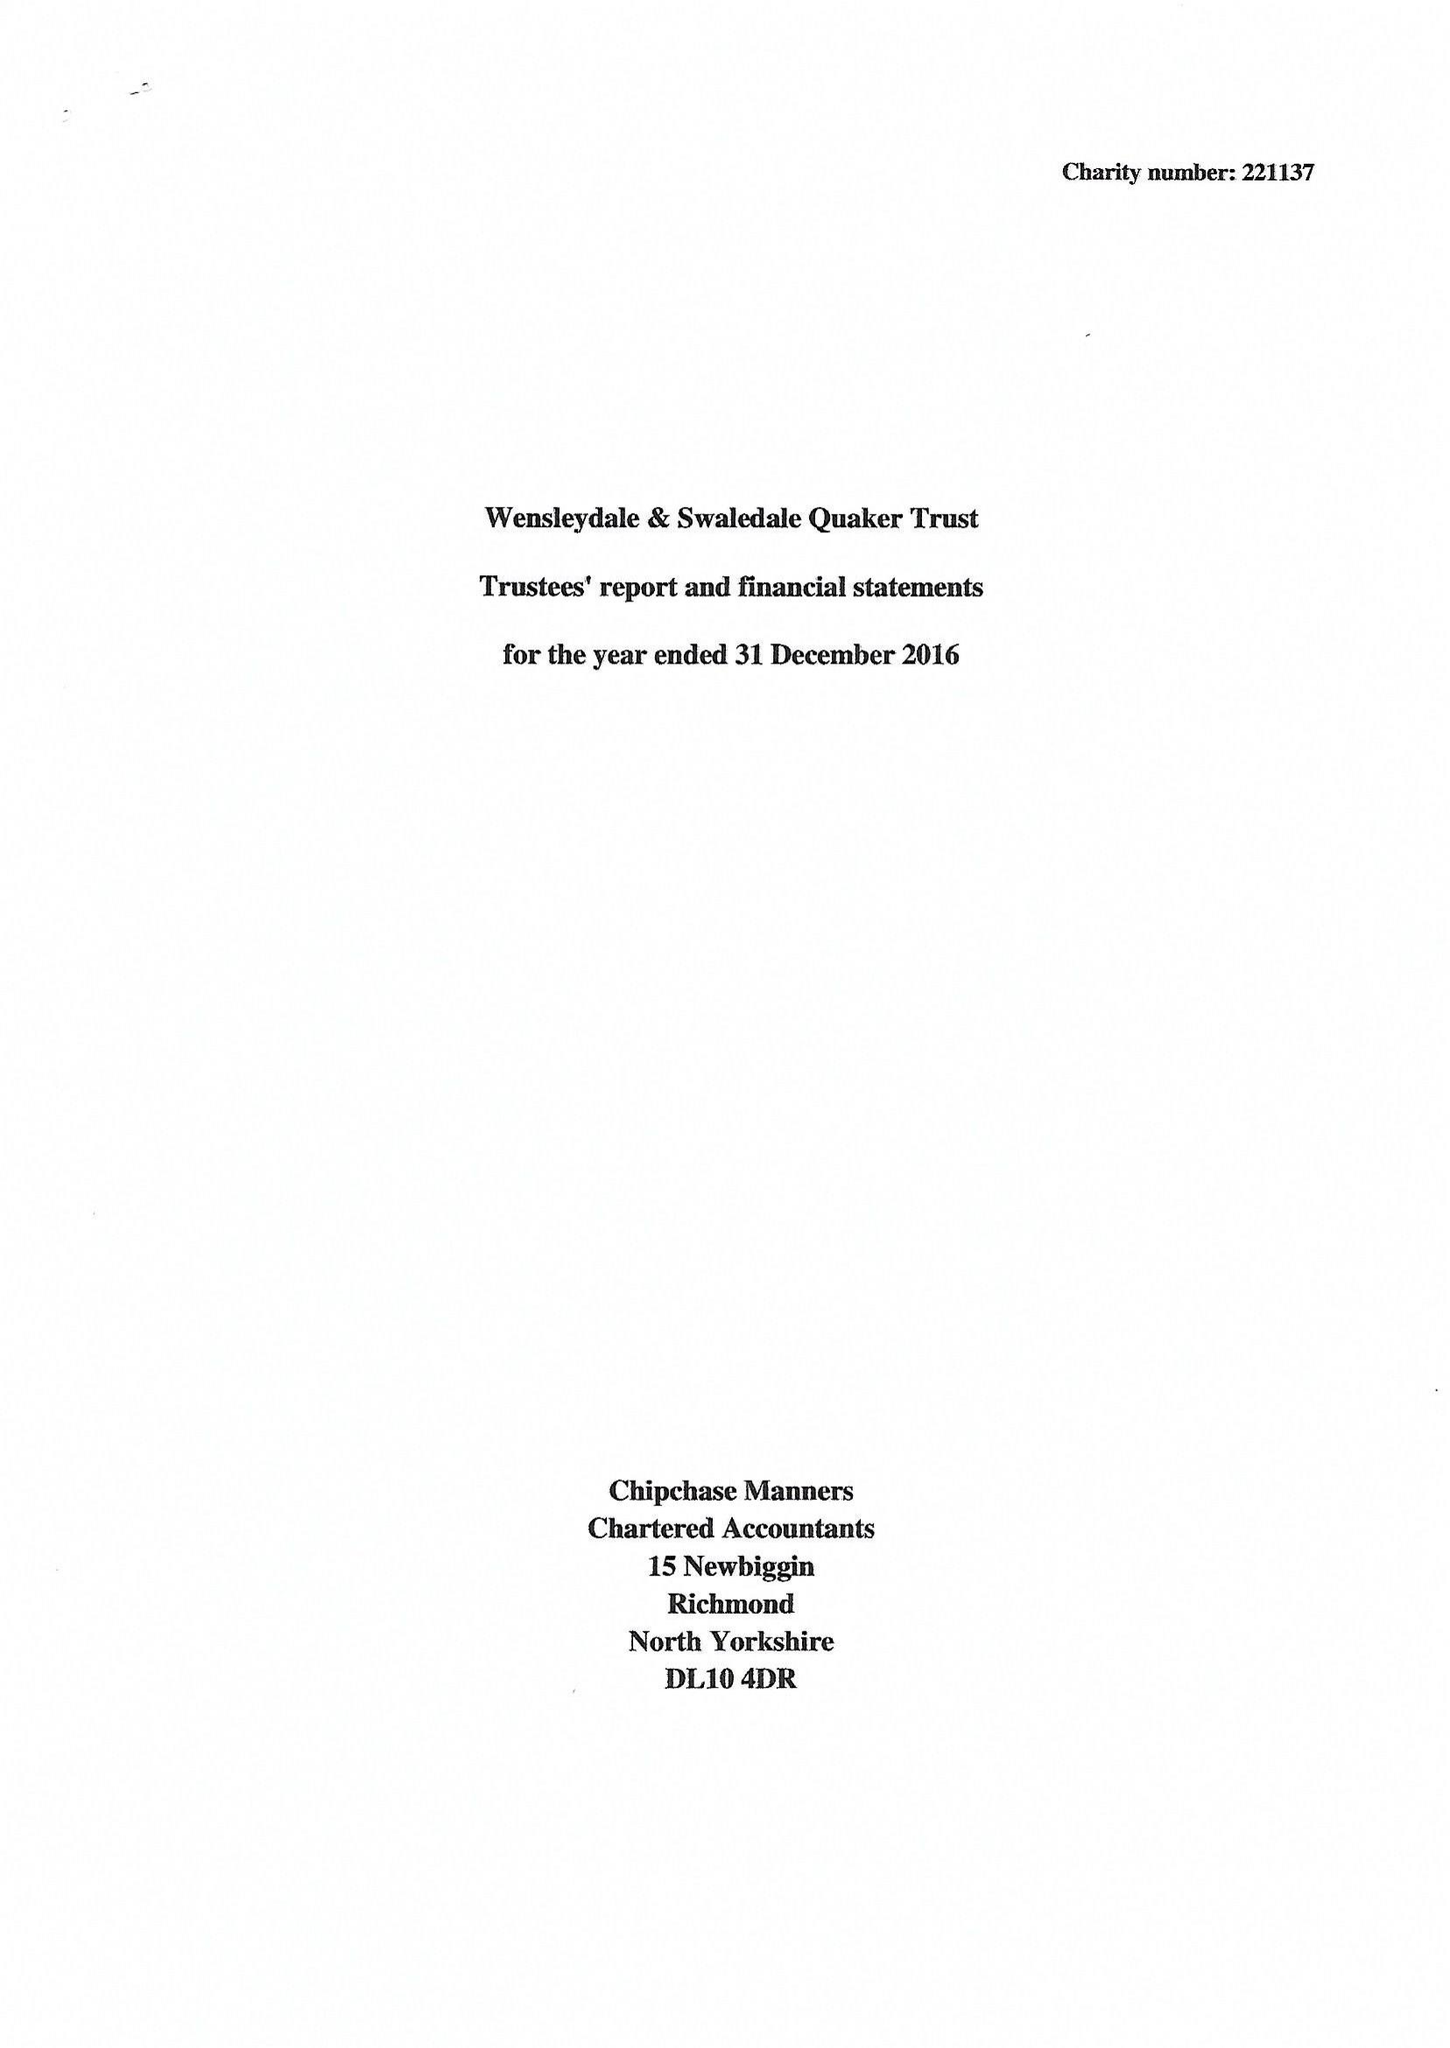What is the value for the income_annually_in_british_pounds?
Answer the question using a single word or phrase. 49154.00 